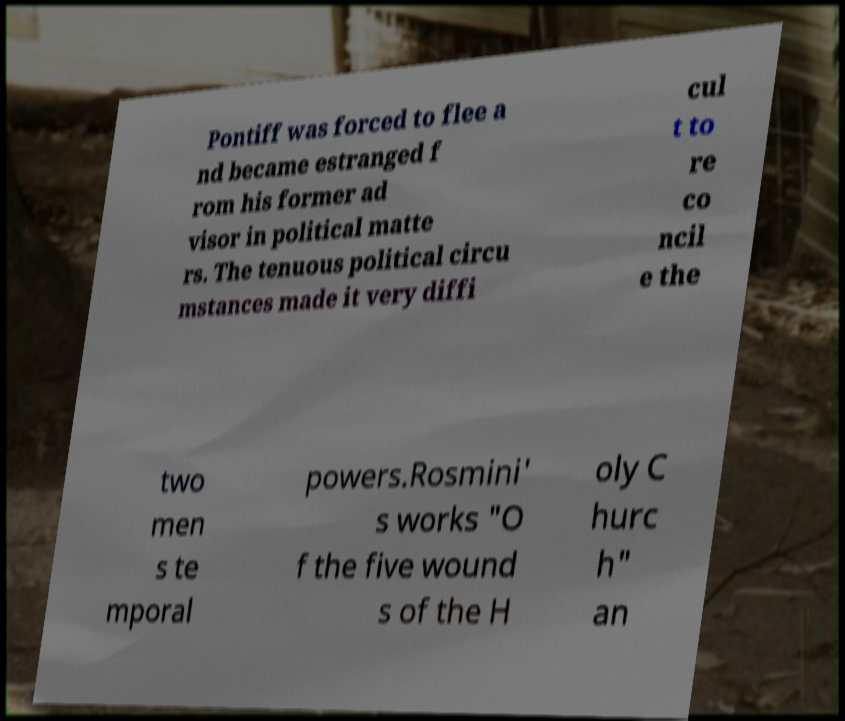I need the written content from this picture converted into text. Can you do that? Pontiff was forced to flee a nd became estranged f rom his former ad visor in political matte rs. The tenuous political circu mstances made it very diffi cul t to re co ncil e the two men s te mporal powers.Rosmini' s works "O f the five wound s of the H oly C hurc h" an 